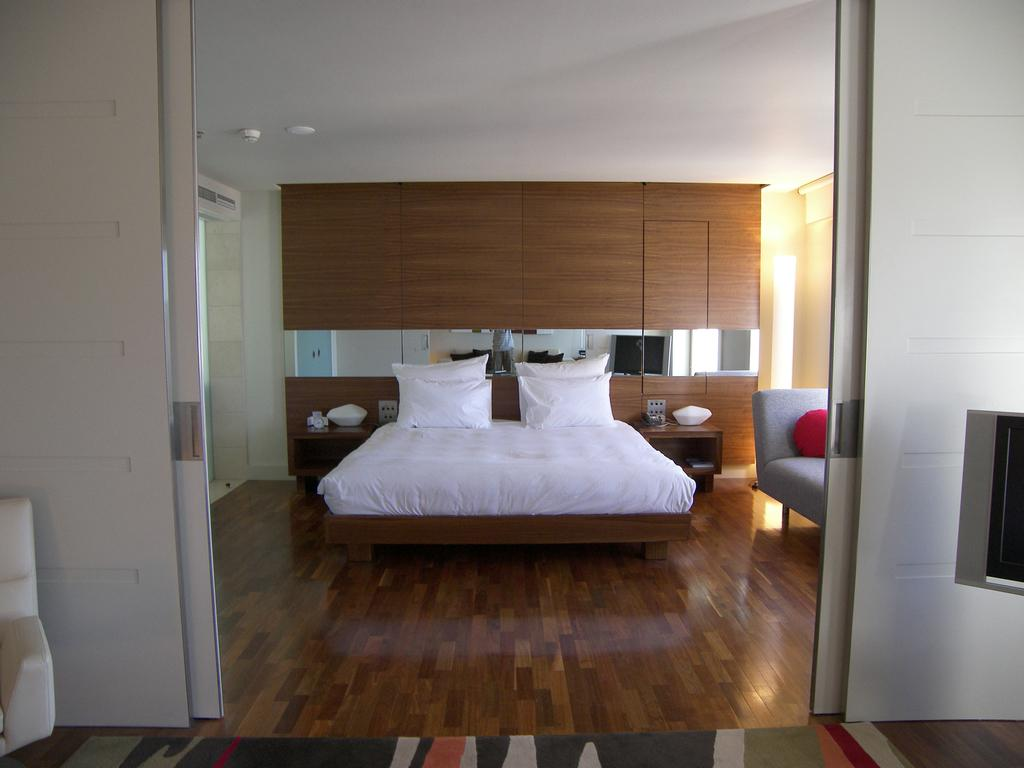What is the main object in the middle of the image? There is a bed in the middle of the image. What color is the bed? The bed is white. What can be seen on top of the bed? There are pillows on the bed. What part of a building can be seen at the top of the image? The roof is visible at the top of the image. What advice is the bed giving to the person in the image? The bed is not capable of giving advice, as it is an inanimate object. 